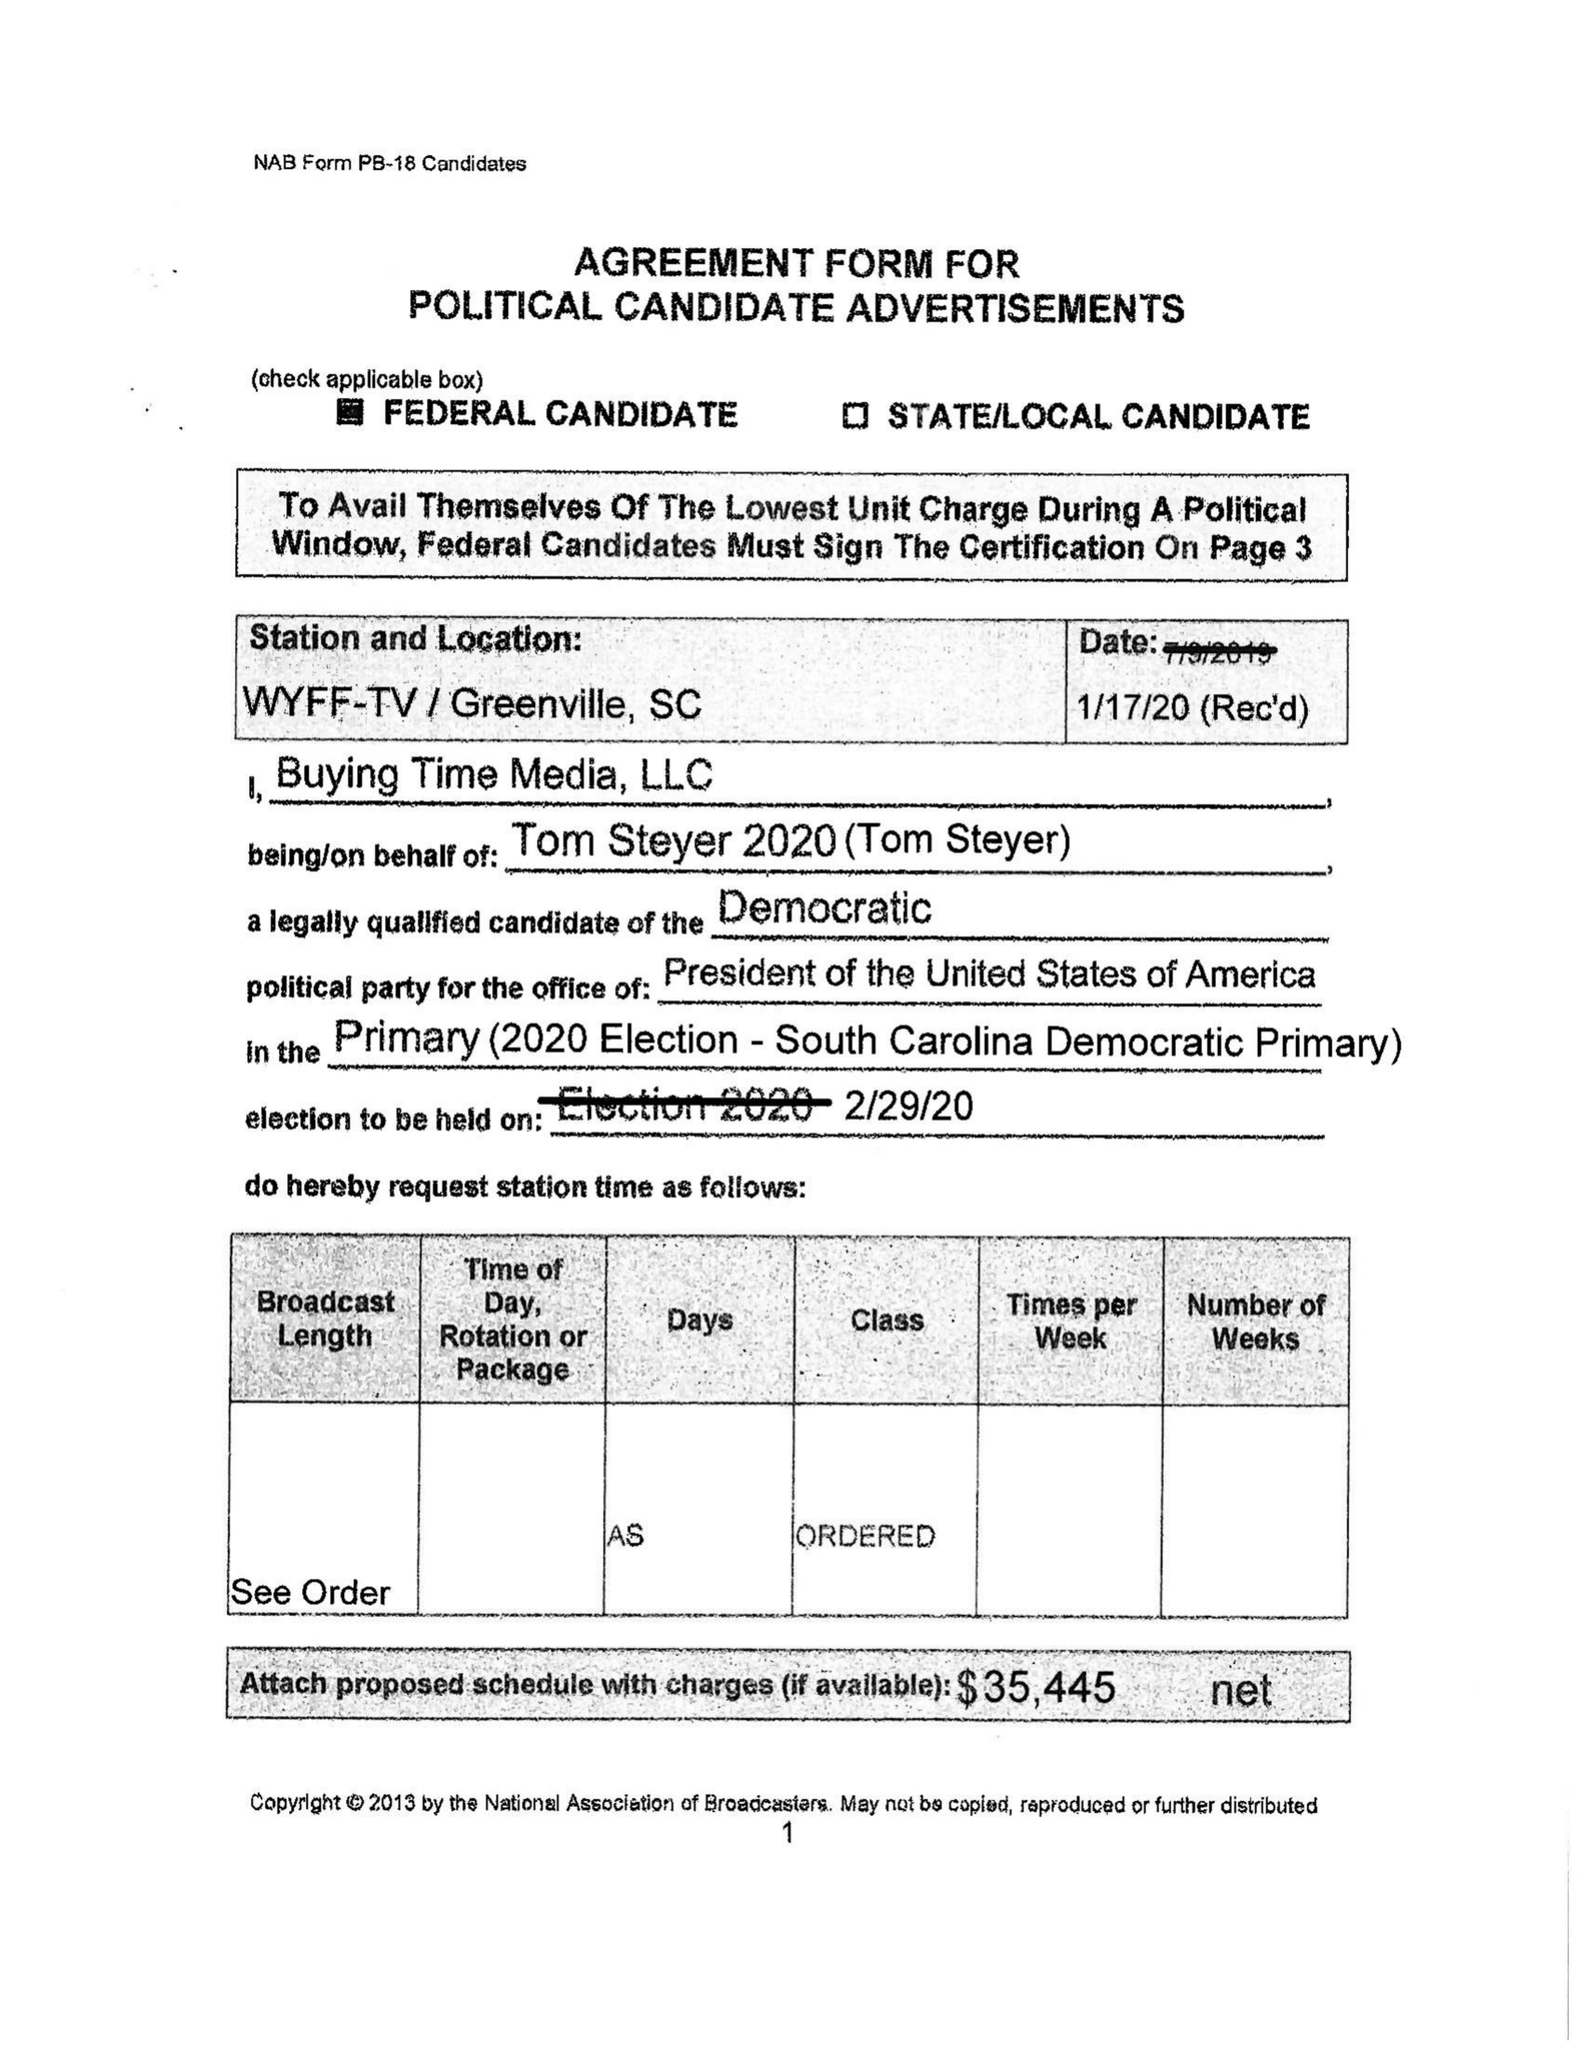What is the value for the contract_num?
Answer the question using a single word or phrase. None 